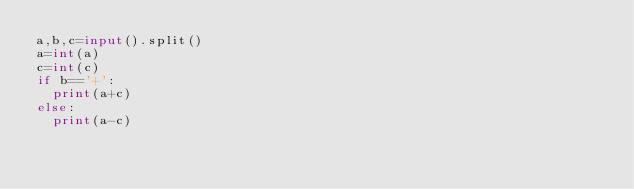Convert code to text. <code><loc_0><loc_0><loc_500><loc_500><_Python_>a,b,c=input().split()
a=int(a)
c=int(c)
if b=='+':
  print(a+c)
else:
  print(a-c)</code> 